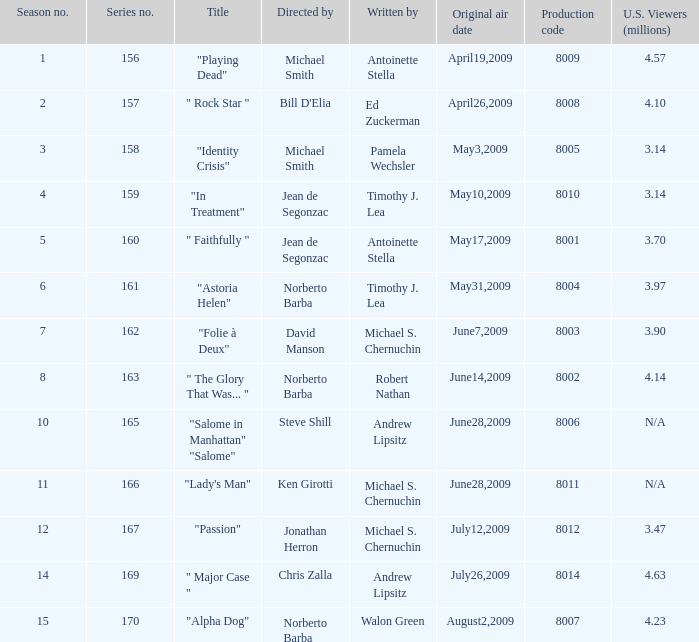What is the designation of the episode authored by timothy j. lea and overseen by norberto barba? "Astoria Helen". 